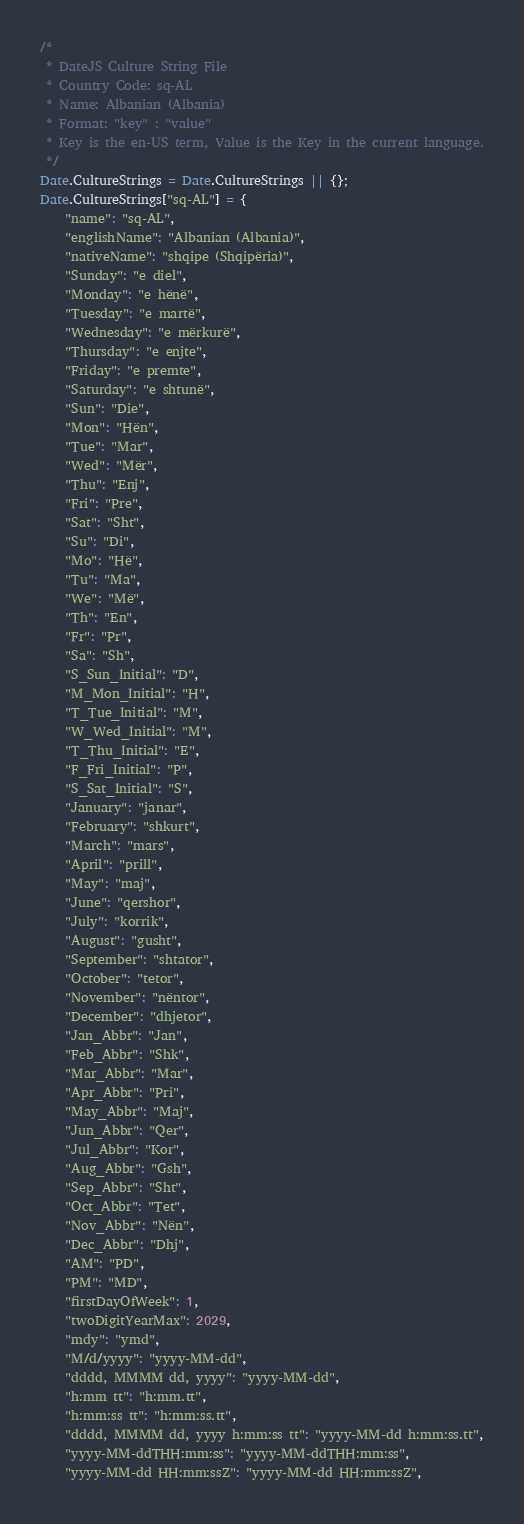<code> <loc_0><loc_0><loc_500><loc_500><_JavaScript_>/* 
 * DateJS Culture String File
 * Country Code: sq-AL
 * Name: Albanian (Albania)
 * Format: "key" : "value"
 * Key is the en-US term, Value is the Key in the current language.
 */
Date.CultureStrings = Date.CultureStrings || {};
Date.CultureStrings["sq-AL"] = {
    "name": "sq-AL",
    "englishName": "Albanian (Albania)",
    "nativeName": "shqipe (Shqipëria)",
    "Sunday": "e diel",
    "Monday": "e hënë",
    "Tuesday": "e martë",
    "Wednesday": "e mërkurë",
    "Thursday": "e enjte",
    "Friday": "e premte",
    "Saturday": "e shtunë",
    "Sun": "Die",
    "Mon": "Hën",
    "Tue": "Mar",
    "Wed": "Mër",
    "Thu": "Enj",
    "Fri": "Pre",
    "Sat": "Sht",
    "Su": "Di",
    "Mo": "Hë",
    "Tu": "Ma",
    "We": "Më",
    "Th": "En",
    "Fr": "Pr",
    "Sa": "Sh",
    "S_Sun_Initial": "D",
    "M_Mon_Initial": "H",
    "T_Tue_Initial": "M",
    "W_Wed_Initial": "M",
    "T_Thu_Initial": "E",
    "F_Fri_Initial": "P",
    "S_Sat_Initial": "S",
    "January": "janar",
    "February": "shkurt",
    "March": "mars",
    "April": "prill",
    "May": "maj",
    "June": "qershor",
    "July": "korrik",
    "August": "gusht",
    "September": "shtator",
    "October": "tetor",
    "November": "nëntor",
    "December": "dhjetor",
    "Jan_Abbr": "Jan",
    "Feb_Abbr": "Shk",
    "Mar_Abbr": "Mar",
    "Apr_Abbr": "Pri",
    "May_Abbr": "Maj",
    "Jun_Abbr": "Qer",
    "Jul_Abbr": "Kor",
    "Aug_Abbr": "Gsh",
    "Sep_Abbr": "Sht",
    "Oct_Abbr": "Tet",
    "Nov_Abbr": "Nën",
    "Dec_Abbr": "Dhj",
    "AM": "PD",
    "PM": "MD",
    "firstDayOfWeek": 1,
    "twoDigitYearMax": 2029,
    "mdy": "ymd",
    "M/d/yyyy": "yyyy-MM-dd",
    "dddd, MMMM dd, yyyy": "yyyy-MM-dd",
    "h:mm tt": "h:mm.tt",
    "h:mm:ss tt": "h:mm:ss.tt",
    "dddd, MMMM dd, yyyy h:mm:ss tt": "yyyy-MM-dd h:mm:ss.tt",
    "yyyy-MM-ddTHH:mm:ss": "yyyy-MM-ddTHH:mm:ss",
    "yyyy-MM-dd HH:mm:ssZ": "yyyy-MM-dd HH:mm:ssZ",</code> 